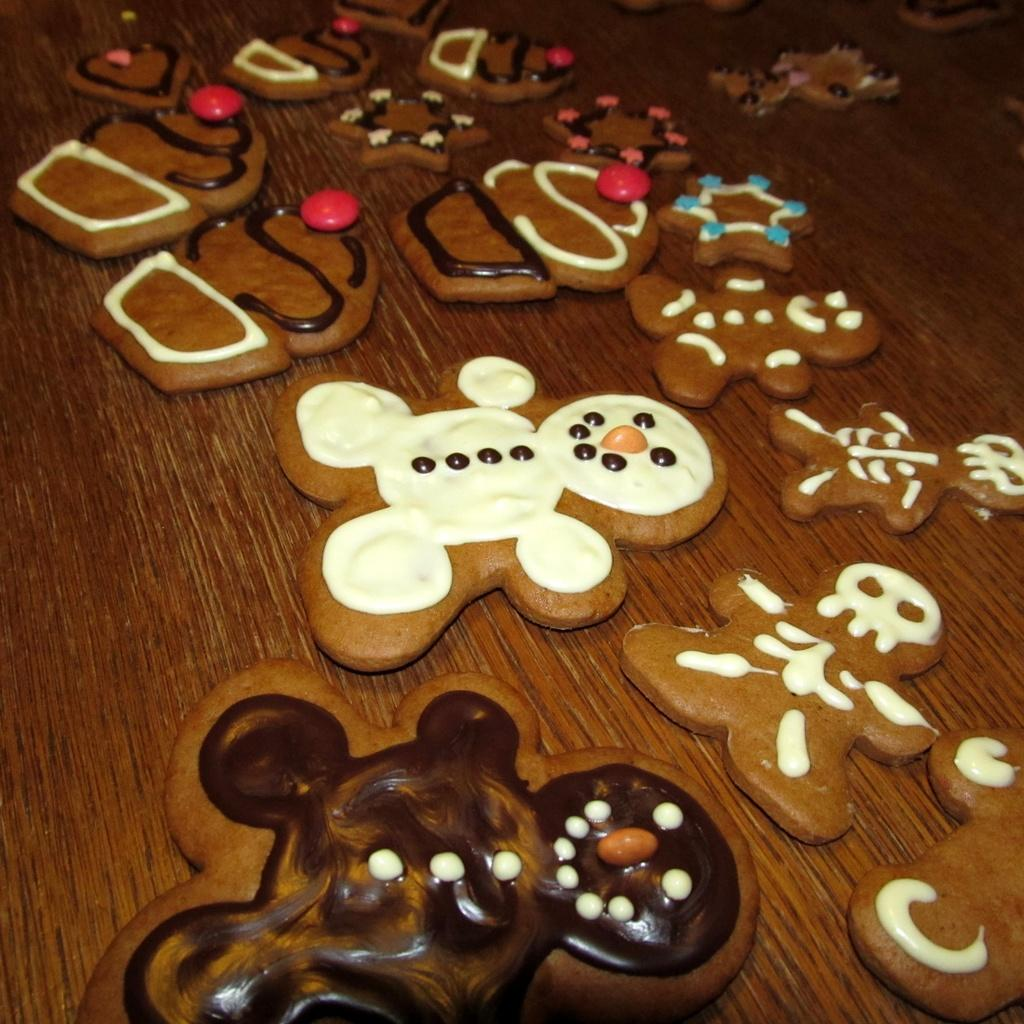What is located in the foreground of the image? There is a table in the foreground of the image. What type of food can be seen on the table? There are cookies on the table. What type of bulb is visible on the table in the image? There is no bulb visible on the table in the image. How does the table provide comfort in the image? The table does not provide comfort in the image; it is an inanimate object. 